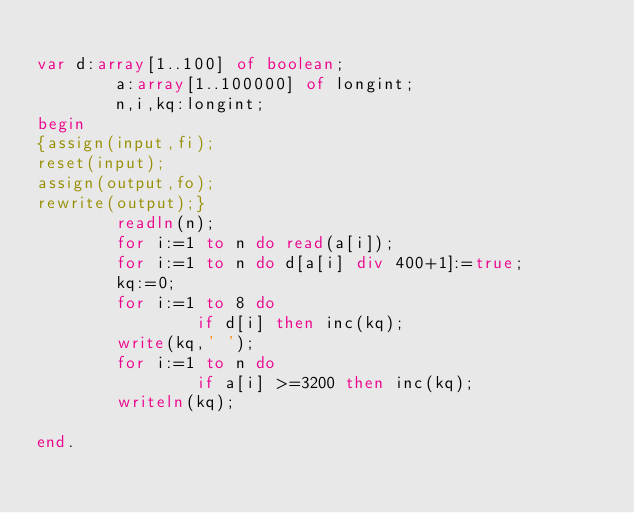<code> <loc_0><loc_0><loc_500><loc_500><_Pascal_>
var d:array[1..100] of boolean;
        a:array[1..100000] of longint;
        n,i,kq:longint;
begin
{assign(input,fi);
reset(input);
assign(output,fo);
rewrite(output);}
        readln(n);
        for i:=1 to n do read(a[i]);
        for i:=1 to n do d[a[i] div 400+1]:=true;
        kq:=0;
        for i:=1 to 8 do
                if d[i] then inc(kq);
        write(kq,' ');
        for i:=1 to n do
                if a[i] >=3200 then inc(kq);
        writeln(kq);

end.
</code> 